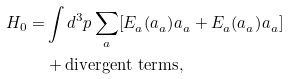Convert formula to latex. <formula><loc_0><loc_0><loc_500><loc_500>H _ { 0 } = & \int d ^ { 3 } p \sum _ { a } [ E _ { a } ^ { } ( a _ { a } ^ { } ) ^ { } a _ { a } ^ { } + E _ { a } ^ { } ( a _ { a } ^ { } ) ^ { } a _ { a } ^ { } ] \\ & + \text {divergent terms} ,</formula> 